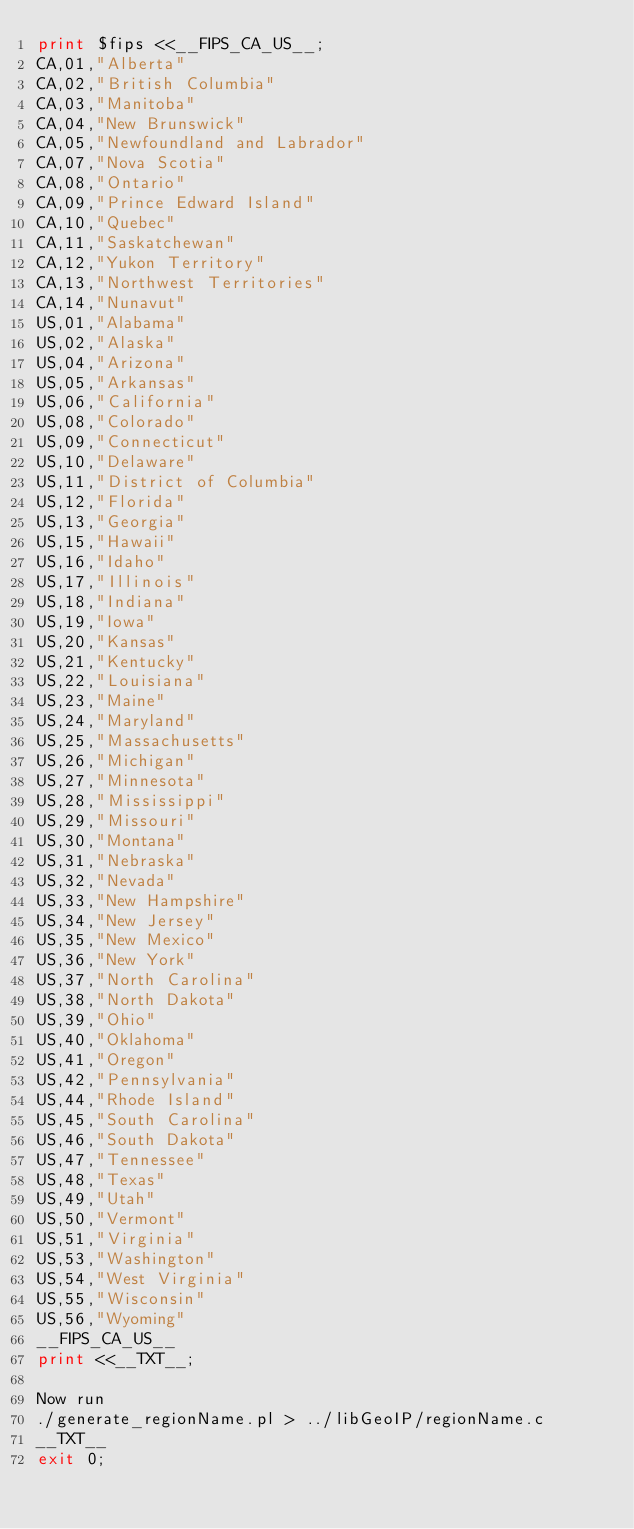Convert code to text. <code><loc_0><loc_0><loc_500><loc_500><_Perl_>print $fips <<__FIPS_CA_US__;
CA,01,"Alberta"
CA,02,"British Columbia"
CA,03,"Manitoba"
CA,04,"New Brunswick"
CA,05,"Newfoundland and Labrador"
CA,07,"Nova Scotia"
CA,08,"Ontario"
CA,09,"Prince Edward Island"
CA,10,"Quebec"
CA,11,"Saskatchewan"
CA,12,"Yukon Territory"
CA,13,"Northwest Territories"
CA,14,"Nunavut"
US,01,"Alabama"
US,02,"Alaska"
US,04,"Arizona"
US,05,"Arkansas"
US,06,"California"
US,08,"Colorado"
US,09,"Connecticut"
US,10,"Delaware"
US,11,"District of Columbia"
US,12,"Florida"
US,13,"Georgia"
US,15,"Hawaii"
US,16,"Idaho"
US,17,"Illinois"
US,18,"Indiana"
US,19,"Iowa"
US,20,"Kansas"
US,21,"Kentucky"
US,22,"Louisiana"
US,23,"Maine"
US,24,"Maryland"
US,25,"Massachusetts"
US,26,"Michigan"
US,27,"Minnesota"
US,28,"Mississippi"
US,29,"Missouri"
US,30,"Montana"
US,31,"Nebraska"
US,32,"Nevada"
US,33,"New Hampshire"
US,34,"New Jersey"
US,35,"New Mexico"
US,36,"New York"
US,37,"North Carolina"
US,38,"North Dakota"
US,39,"Ohio"
US,40,"Oklahoma"
US,41,"Oregon"
US,42,"Pennsylvania"
US,44,"Rhode Island"
US,45,"South Carolina"
US,46,"South Dakota"
US,47,"Tennessee"
US,48,"Texas"
US,49,"Utah"
US,50,"Vermont"
US,51,"Virginia"
US,53,"Washington"
US,54,"West Virginia"
US,55,"Wisconsin"
US,56,"Wyoming"
__FIPS_CA_US__
print <<__TXT__;

Now run
./generate_regionName.pl > ../libGeoIP/regionName.c
__TXT__
exit 0;
</code> 